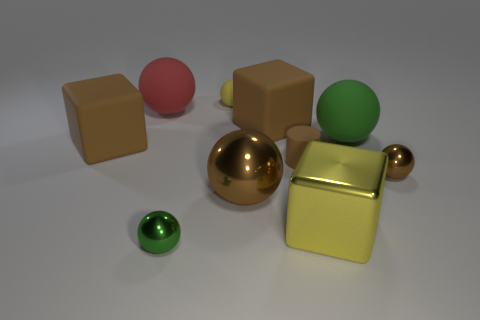Subtract all large red balls. How many balls are left? 5 Subtract all yellow spheres. How many spheres are left? 5 Subtract all yellow spheres. Subtract all green cylinders. How many spheres are left? 5 Subtract all spheres. How many objects are left? 4 Add 9 small gray shiny balls. How many small gray shiny balls exist? 9 Subtract 0 red blocks. How many objects are left? 10 Subtract all large brown things. Subtract all yellow matte spheres. How many objects are left? 6 Add 7 tiny yellow rubber balls. How many tiny yellow rubber balls are left? 8 